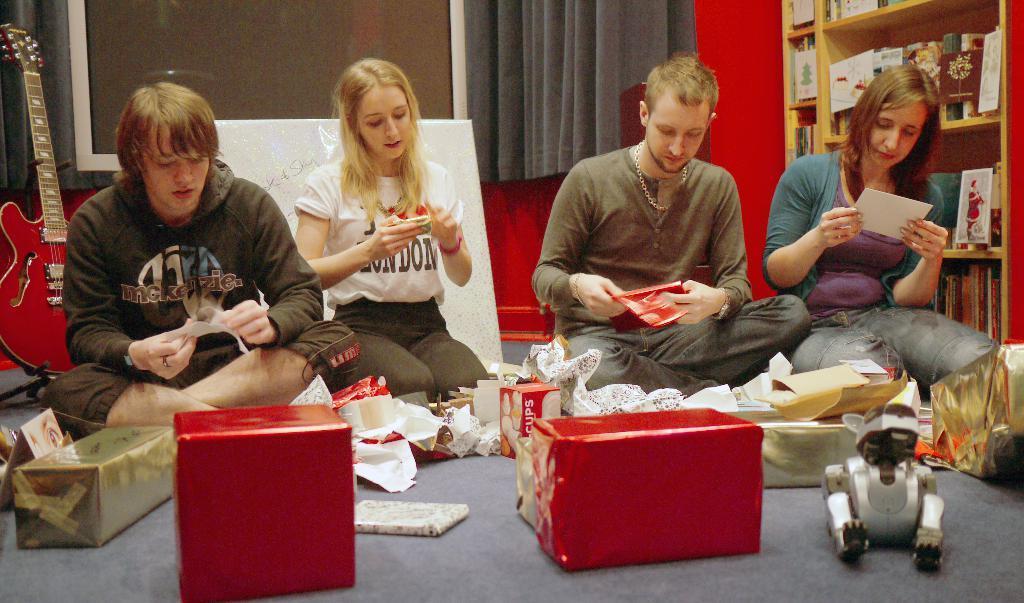Please provide a concise description of this image. In the picture we can see a four people are sitting on the floor and watching the greeting cards and their hands and to the floor beside them, we can see some red color boxes with papers and to the wall we can see a curtain and on the floor, we can see a guitar which is red in color and on the other side we can see a rack with books and some greeting cards in it. 